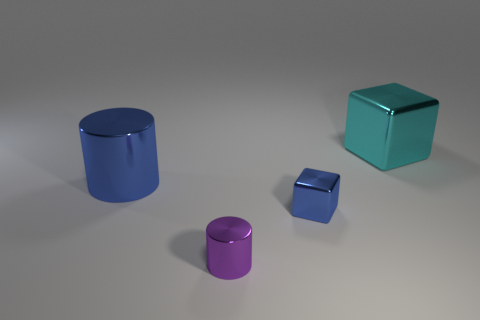Is there a big gray metallic sphere?
Keep it short and to the point. No. Is the number of large metallic objects that are on the right side of the big blue shiny thing greater than the number of small blue blocks in front of the small blue metal block?
Your response must be concise. Yes. There is a shiny object that is in front of the small thing that is behind the small purple metallic object; what color is it?
Your answer should be very brief. Purple. Is there a cylinder of the same color as the tiny metallic cube?
Offer a very short reply. Yes. There is a thing left of the small metallic object that is in front of the blue metallic object that is on the right side of the blue cylinder; what size is it?
Your answer should be very brief. Large. What is the shape of the small blue object?
Your answer should be very brief. Cube. There is a cylinder that is the same color as the tiny block; what is its size?
Provide a short and direct response. Large. There is a blue metal object on the right side of the large blue cylinder; how many tiny objects are to the left of it?
Keep it short and to the point. 1. What number of other objects are there of the same material as the purple object?
Offer a very short reply. 3. Does the tiny cube in front of the big blue metal object have the same material as the big object to the right of the small purple metal thing?
Offer a very short reply. Yes. 